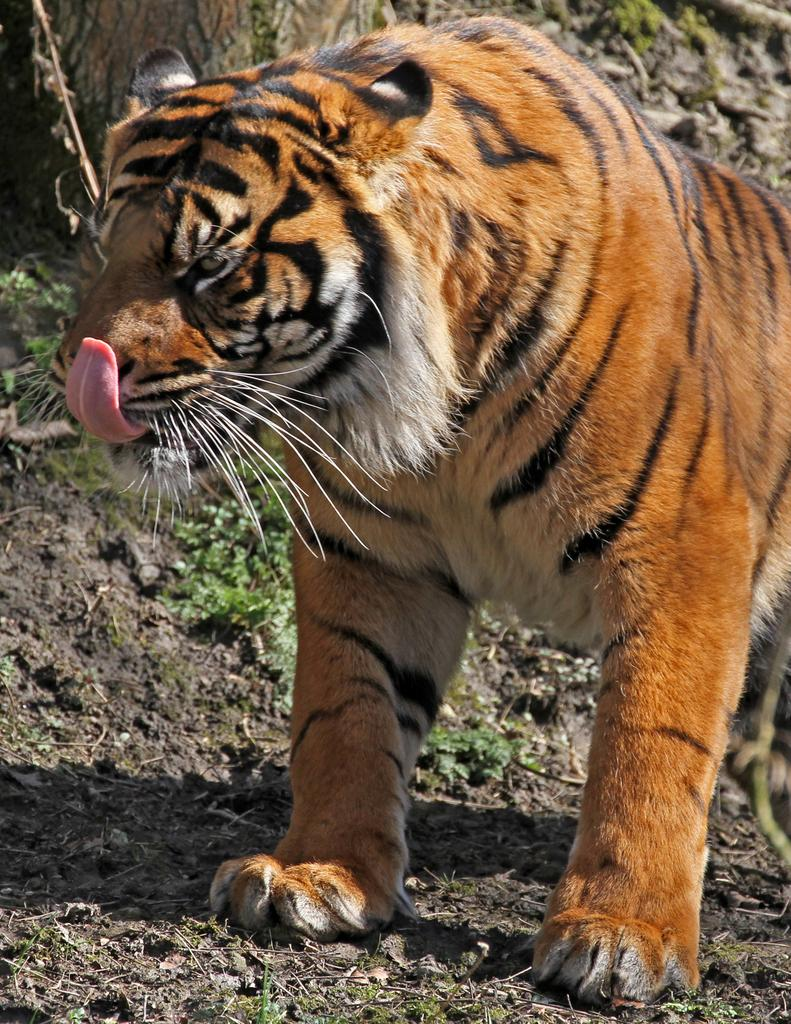What animal is in the image? There is a tiger in the image. Where is the tiger located? The tiger is on the ground. What can be seen in the background of the image? There are plants in the background of the image. What type of spark can be seen coming from the tiger's mouth in the image? There is no spark coming from the tiger's mouth in the image. 